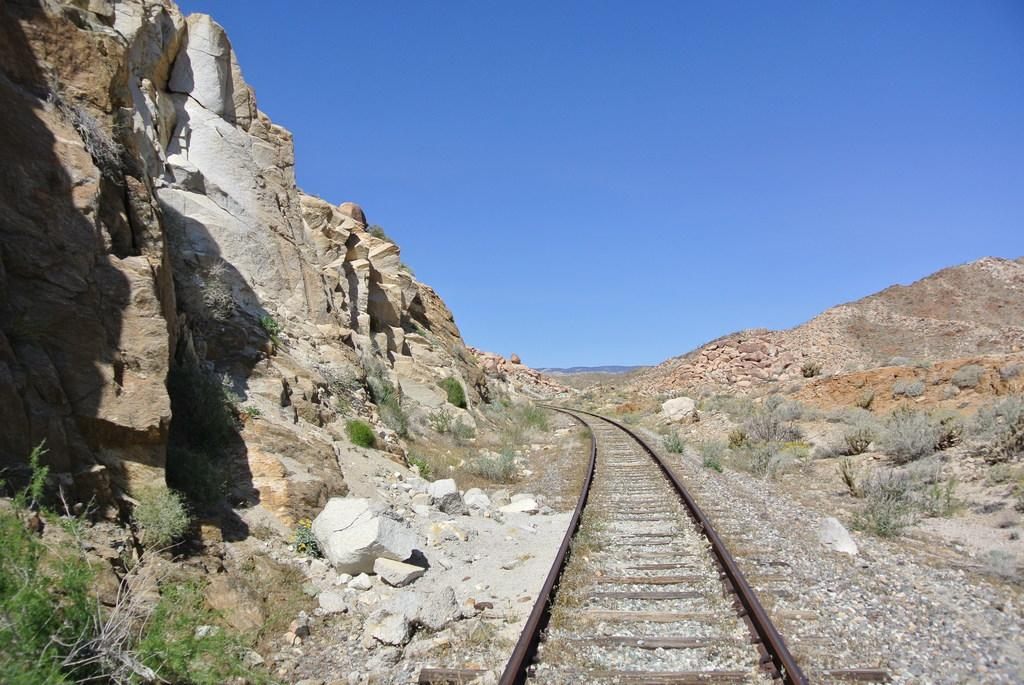What is the main feature of the image? There is a track in the image. What can be seen on both sides of the track? Huge rocks and plants are present on both sides of the track. What is the color of the sky in the background of the image? The blue sky is visible in the background of the image. How many properties are visible in the image? There are no properties visible in the image; it features a track with rocks and plants on both sides. What type of wood is used to build the track in the image? There is no indication of the track being made of wood in the image. 